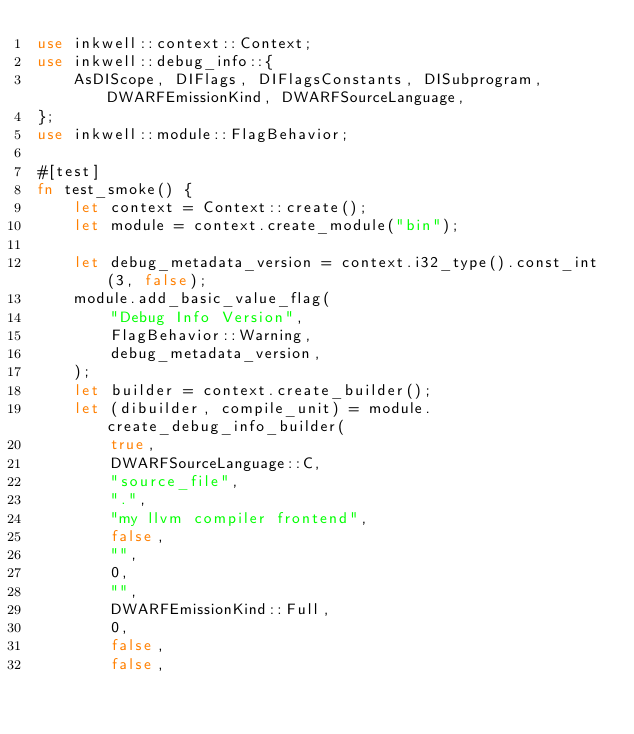<code> <loc_0><loc_0><loc_500><loc_500><_Rust_>use inkwell::context::Context;
use inkwell::debug_info::{
    AsDIScope, DIFlags, DIFlagsConstants, DISubprogram, DWARFEmissionKind, DWARFSourceLanguage,
};
use inkwell::module::FlagBehavior;

#[test]
fn test_smoke() {
    let context = Context::create();
    let module = context.create_module("bin");

    let debug_metadata_version = context.i32_type().const_int(3, false);
    module.add_basic_value_flag(
        "Debug Info Version",
        FlagBehavior::Warning,
        debug_metadata_version,
    );
    let builder = context.create_builder();
    let (dibuilder, compile_unit) = module.create_debug_info_builder(
        true,
        DWARFSourceLanguage::C,
        "source_file",
        ".",
        "my llvm compiler frontend",
        false,
        "",
        0,
        "",
        DWARFEmissionKind::Full,
        0,
        false,
        false,</code> 